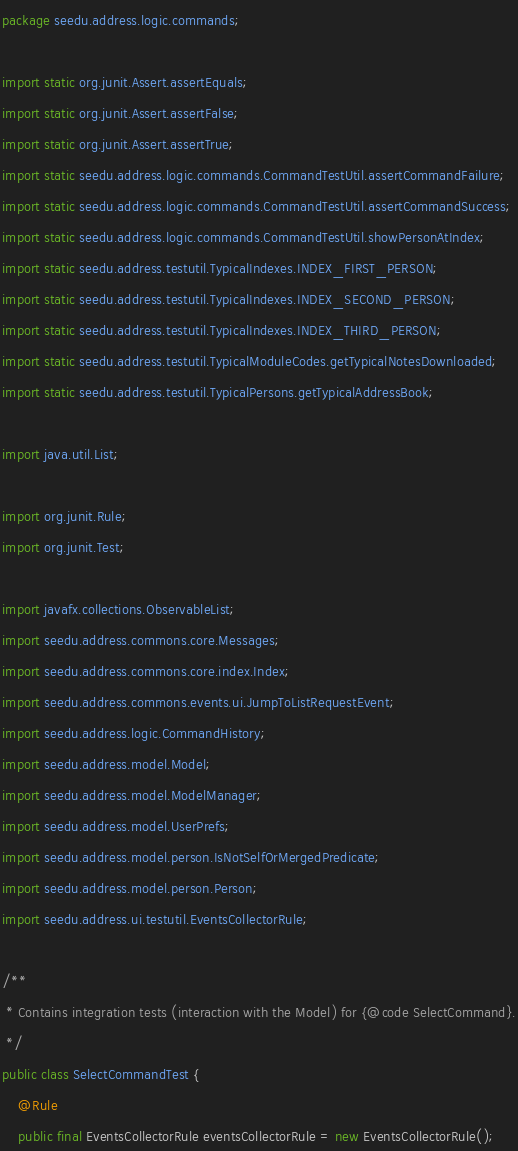<code> <loc_0><loc_0><loc_500><loc_500><_Java_>package seedu.address.logic.commands;

import static org.junit.Assert.assertEquals;
import static org.junit.Assert.assertFalse;
import static org.junit.Assert.assertTrue;
import static seedu.address.logic.commands.CommandTestUtil.assertCommandFailure;
import static seedu.address.logic.commands.CommandTestUtil.assertCommandSuccess;
import static seedu.address.logic.commands.CommandTestUtil.showPersonAtIndex;
import static seedu.address.testutil.TypicalIndexes.INDEX_FIRST_PERSON;
import static seedu.address.testutil.TypicalIndexes.INDEX_SECOND_PERSON;
import static seedu.address.testutil.TypicalIndexes.INDEX_THIRD_PERSON;
import static seedu.address.testutil.TypicalModuleCodes.getTypicalNotesDownloaded;
import static seedu.address.testutil.TypicalPersons.getTypicalAddressBook;

import java.util.List;

import org.junit.Rule;
import org.junit.Test;

import javafx.collections.ObservableList;
import seedu.address.commons.core.Messages;
import seedu.address.commons.core.index.Index;
import seedu.address.commons.events.ui.JumpToListRequestEvent;
import seedu.address.logic.CommandHistory;
import seedu.address.model.Model;
import seedu.address.model.ModelManager;
import seedu.address.model.UserPrefs;
import seedu.address.model.person.IsNotSelfOrMergedPredicate;
import seedu.address.model.person.Person;
import seedu.address.ui.testutil.EventsCollectorRule;

/**
 * Contains integration tests (interaction with the Model) for {@code SelectCommand}.
 */
public class SelectCommandTest {
    @Rule
    public final EventsCollectorRule eventsCollectorRule = new EventsCollectorRule();
</code> 